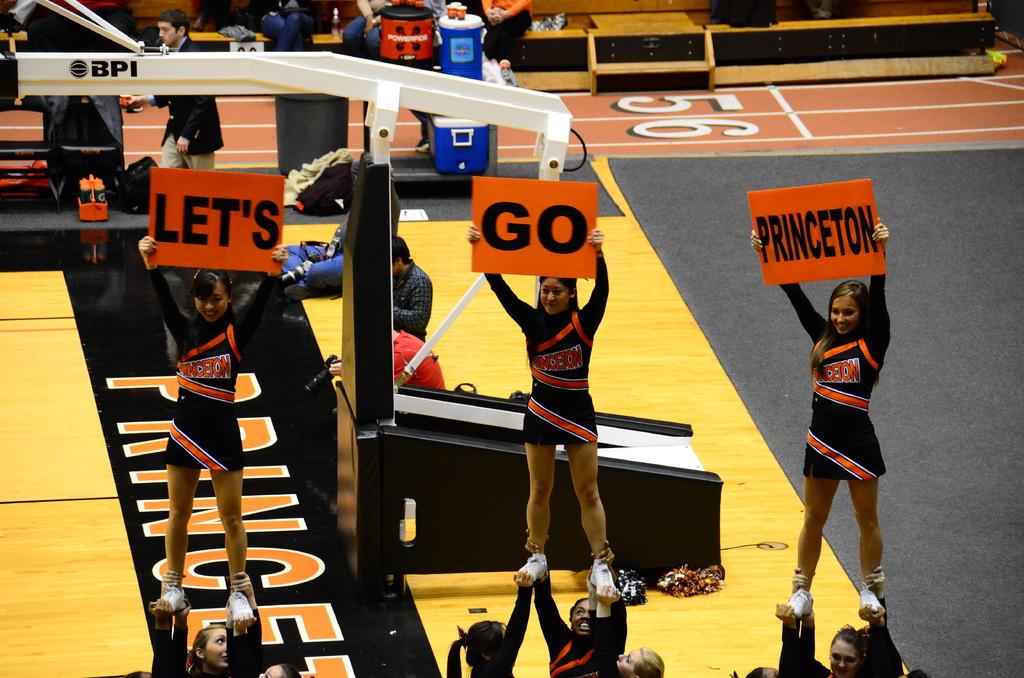<image>
Render a clear and concise summary of the photo. Let's Go Princeton is shown on three signs these cheerleaders are holding. 